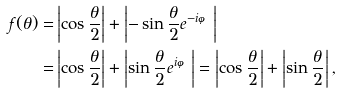<formula> <loc_0><loc_0><loc_500><loc_500>f ( \theta ) = & \left | \cos \frac { \theta } { 2 } \right | + \left | - \sin \frac { \theta } { 2 } e ^ { - i \varphi } \right | \\ = & \left | \cos \frac { \theta } { 2 } \right | + \left | \sin \frac { \theta } { 2 } e ^ { i \varphi } \right | = \left | \cos \frac { \theta } { 2 } \right | + \left | \sin \frac { \theta } { 2 } \right | ,</formula> 